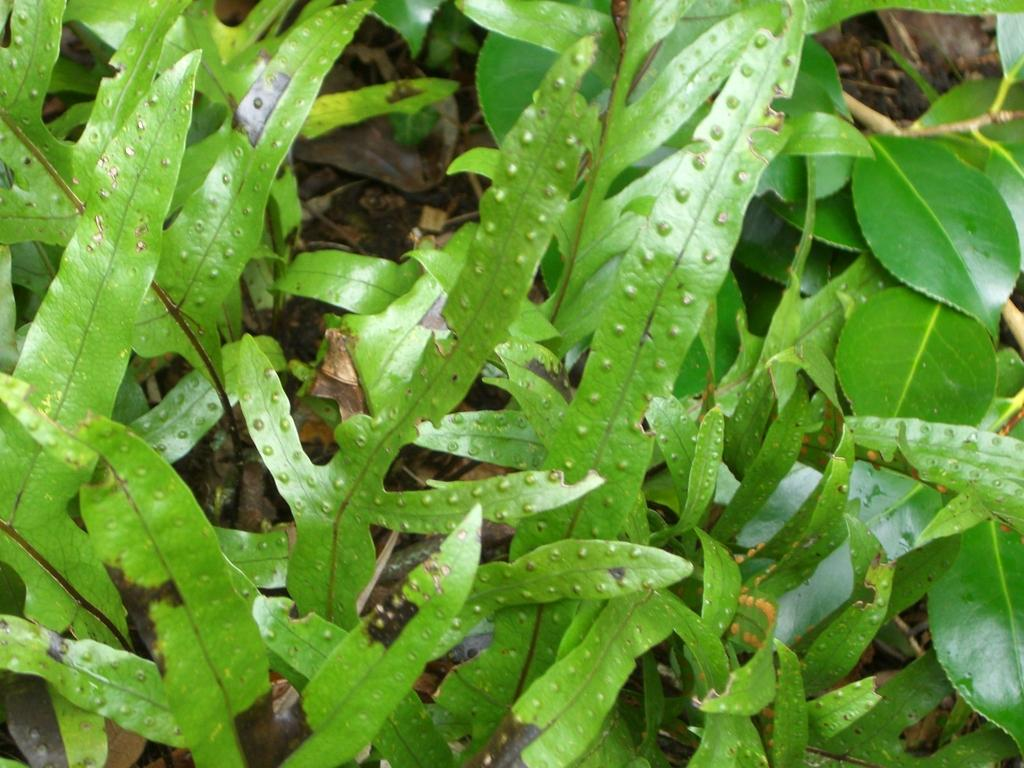What is the primary element visible in the image? There are a lot of leaves in the image. What type of work is being done by the ornament in the image? There is no ornament present in the image, and therefore no work is being done by it. 